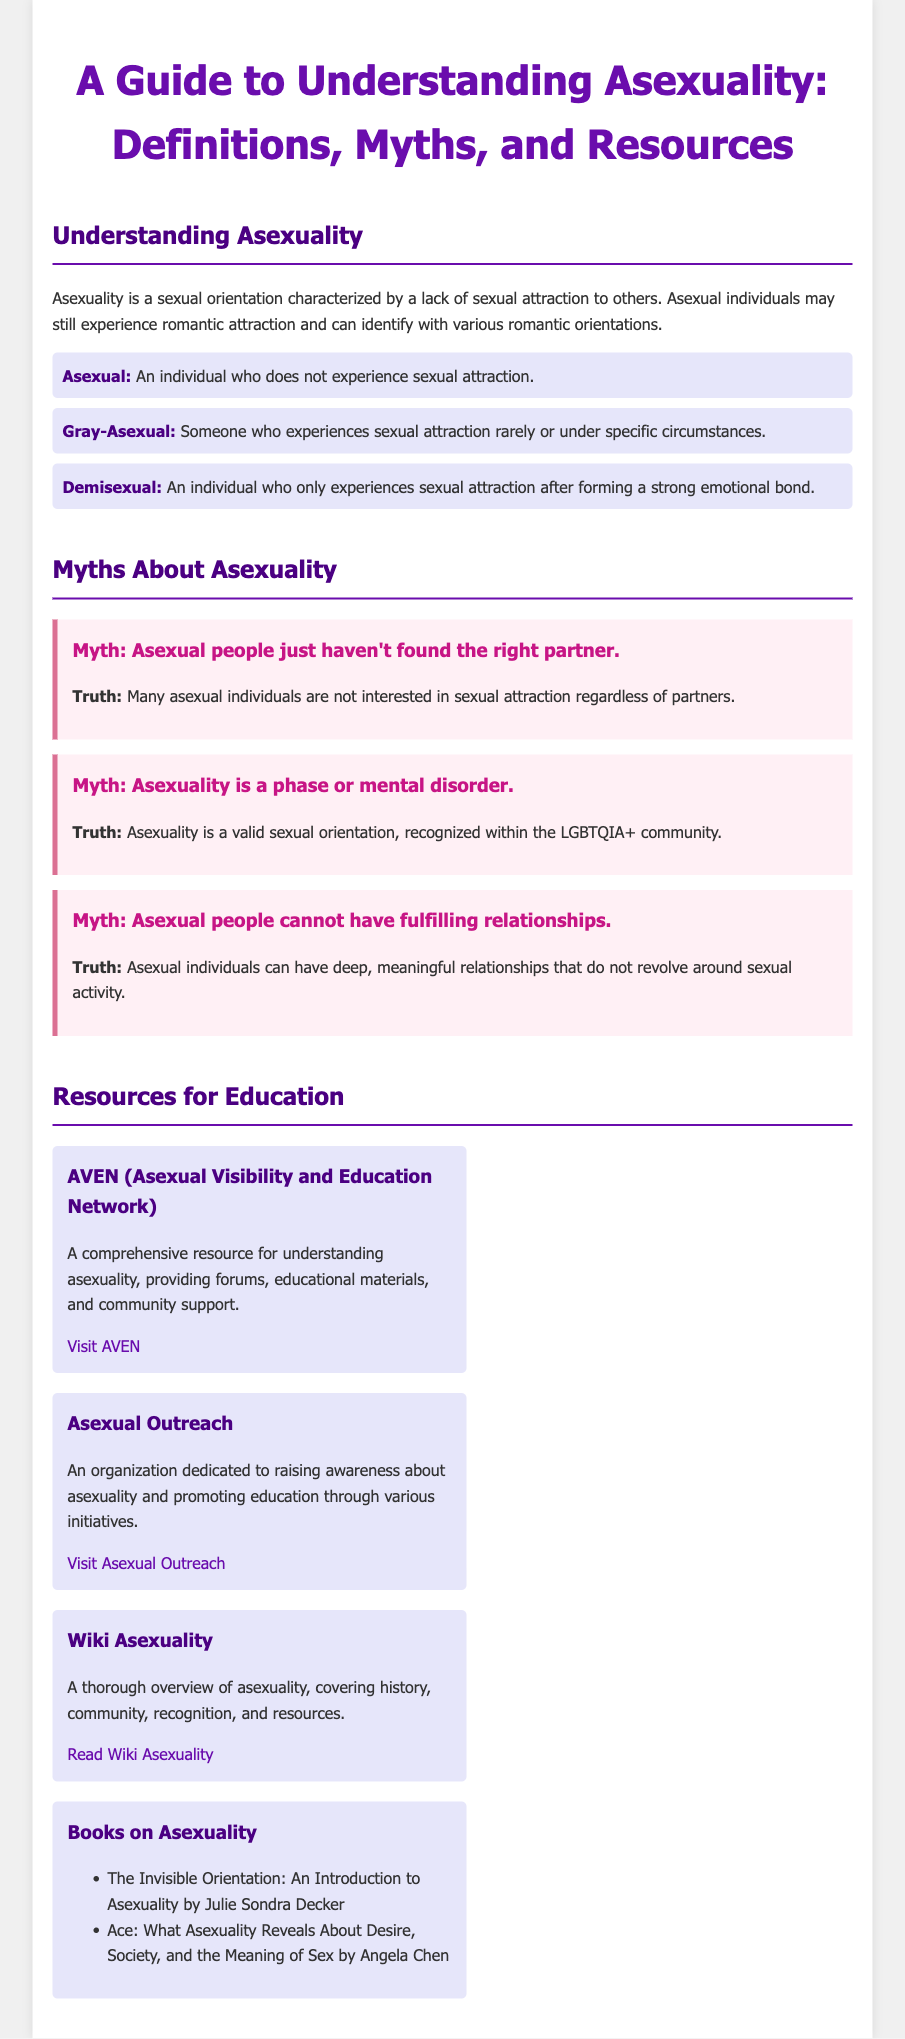What is asexuality? Asexuality is a sexual orientation characterized by a lack of sexual attraction to others.
Answer: Asexuality is a lack of sexual attraction What does "Gray-Asexual" mean? Gray-Asexual refers to someone who experiences sexual attraction rarely or under specific circumstances.
Answer: Someone who experiences sexual attraction rarely What is the common misconception that asexual people just haven't found the right partner? This myth suggests that asexual individuals would become interested in sexual attraction given the right partner.
Answer: Asexual people just haven't found the right partner Which organization provides forums, educational materials, and community support for understanding asexuality? AVEN is mentioned as a comprehensive resource for understanding asexuality.
Answer: AVEN (Asexual Visibility and Education Network) Name one book about asexuality listed in the document. The document lists multiple books on asexuality. One example is "The Invisible Orientation: An Introduction to Asexuality."
Answer: The Invisible Orientation: An Introduction to Asexuality What is the truth about asexuality being a mental disorder? The truth is that asexuality is a valid sexual orientation, recognized within the LGBTQIA+ community.
Answer: Asexuality is a valid sexual orientation How many resources for education are listed in the document? The document lists four resources for education about asexuality.
Answer: Four resources What color is the heading for the "Myths About Asexuality" section? The heading color for the "Myths About Asexuality" section is distinct and colored.
Answer: This section's heading is dark purple What type of attraction do demisexual individuals require before experiencing sexual attraction? Demisexual individuals only experience sexual attraction after forming a strong emotional bond.
Answer: Strong emotional bond 